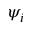<formula> <loc_0><loc_0><loc_500><loc_500>\psi _ { i }</formula> 